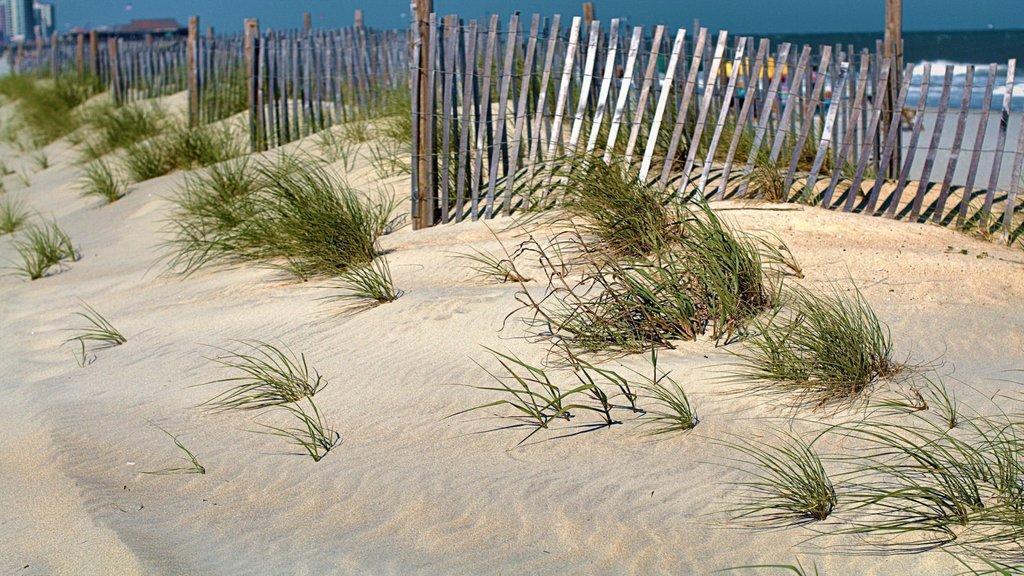Please provide a concise description of this image. In this image there is a fence on the land having some grass. Right side there is water having tides. Top of the image there is sky. Left top there are buildings. 